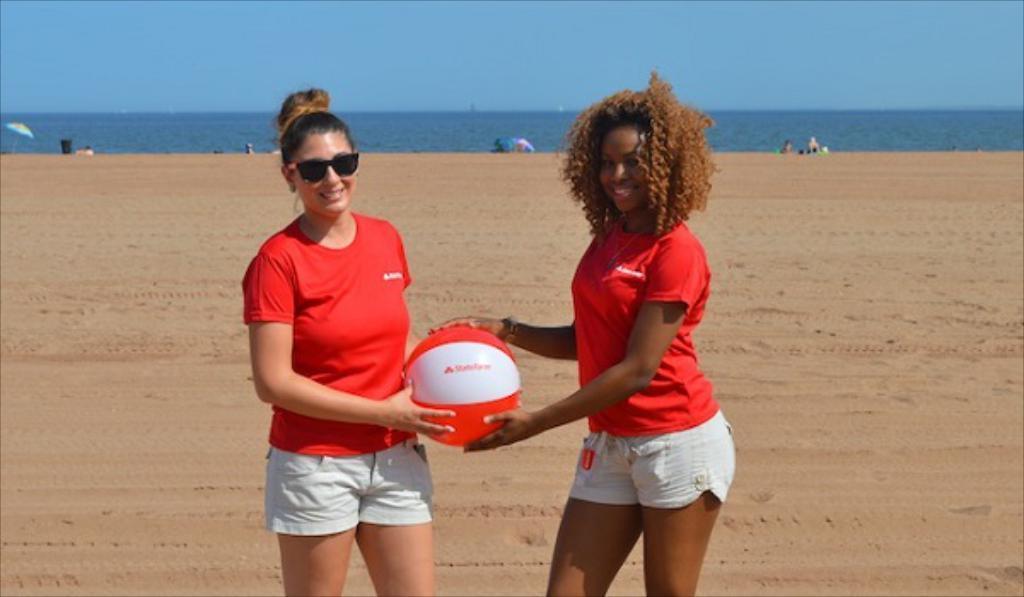Please provide a concise description of this image. In this image I can see 2 women standing and both of them are smiling and both of them are holding a ball. In the background I can see the sand and water and the sky. 